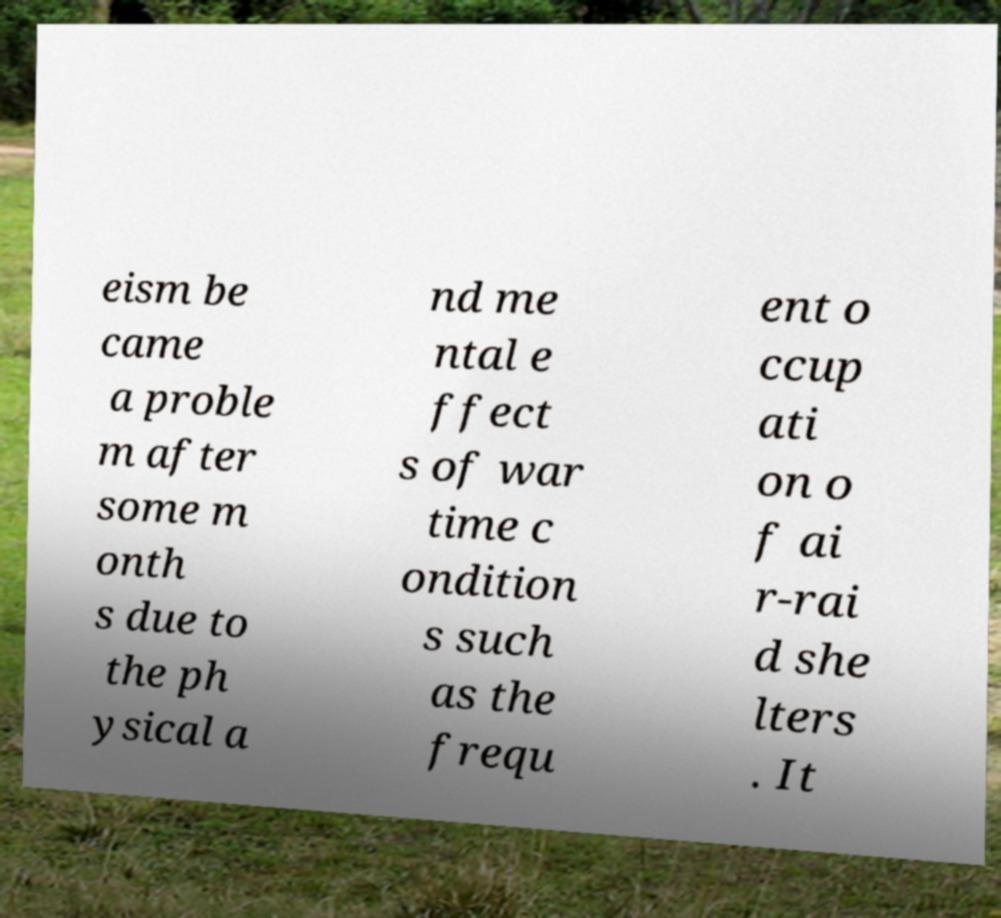For documentation purposes, I need the text within this image transcribed. Could you provide that? eism be came a proble m after some m onth s due to the ph ysical a nd me ntal e ffect s of war time c ondition s such as the frequ ent o ccup ati on o f ai r-rai d she lters . It 